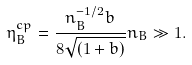<formula> <loc_0><loc_0><loc_500><loc_500>\eta _ { B } ^ { c p } = \frac { n _ { B } ^ { - 1 / 2 } b } { 8 \sqrt { ( 1 + b ) } } n _ { B } \gg 1 .</formula> 